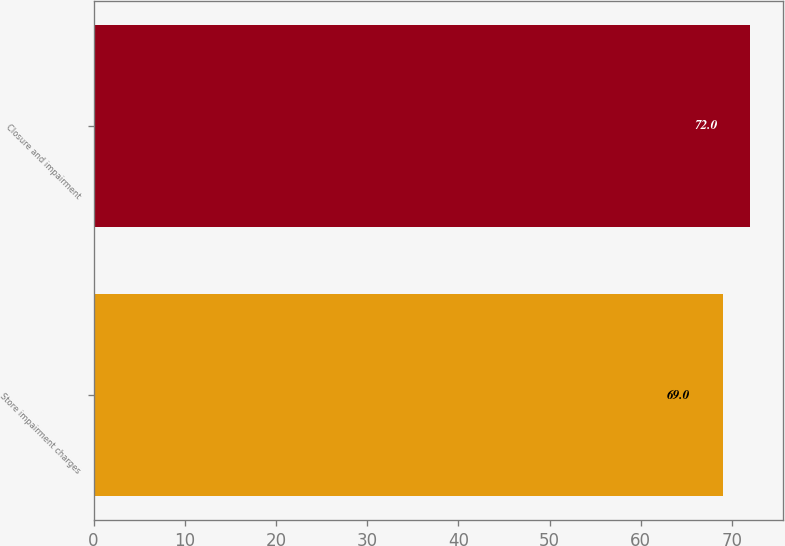<chart> <loc_0><loc_0><loc_500><loc_500><bar_chart><fcel>Store impairment charges<fcel>Closure and impairment<nl><fcel>69<fcel>72<nl></chart> 